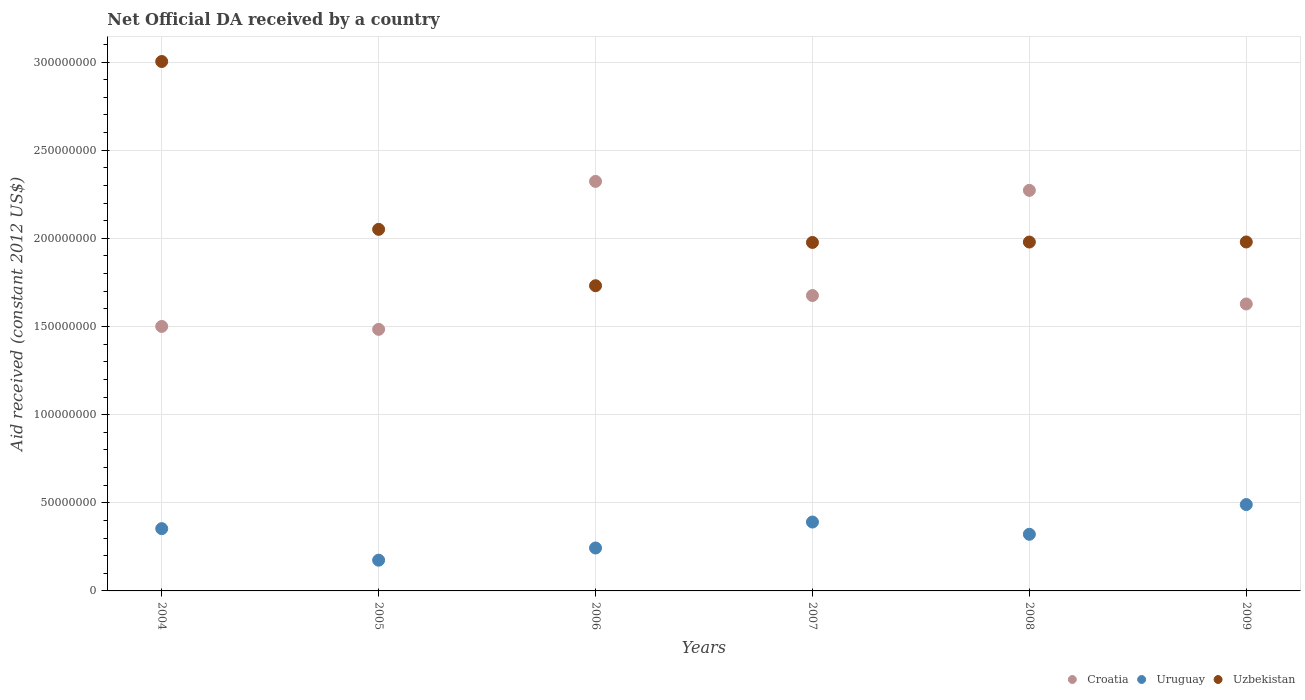How many different coloured dotlines are there?
Provide a succinct answer. 3. What is the net official development assistance aid received in Uruguay in 2008?
Your answer should be very brief. 3.21e+07. Across all years, what is the maximum net official development assistance aid received in Uruguay?
Offer a very short reply. 4.90e+07. Across all years, what is the minimum net official development assistance aid received in Uzbekistan?
Make the answer very short. 1.73e+08. In which year was the net official development assistance aid received in Uzbekistan maximum?
Make the answer very short. 2004. In which year was the net official development assistance aid received in Croatia minimum?
Make the answer very short. 2005. What is the total net official development assistance aid received in Croatia in the graph?
Ensure brevity in your answer.  1.09e+09. What is the difference between the net official development assistance aid received in Croatia in 2004 and that in 2007?
Provide a short and direct response. -1.75e+07. What is the difference between the net official development assistance aid received in Croatia in 2004 and the net official development assistance aid received in Uzbekistan in 2009?
Provide a succinct answer. -4.79e+07. What is the average net official development assistance aid received in Uruguay per year?
Your response must be concise. 3.29e+07. In the year 2007, what is the difference between the net official development assistance aid received in Croatia and net official development assistance aid received in Uruguay?
Your answer should be compact. 1.28e+08. In how many years, is the net official development assistance aid received in Uruguay greater than 130000000 US$?
Provide a succinct answer. 0. What is the ratio of the net official development assistance aid received in Uzbekistan in 2004 to that in 2008?
Your response must be concise. 1.52. What is the difference between the highest and the second highest net official development assistance aid received in Uzbekistan?
Provide a succinct answer. 9.52e+07. What is the difference between the highest and the lowest net official development assistance aid received in Uzbekistan?
Provide a succinct answer. 1.27e+08. In how many years, is the net official development assistance aid received in Croatia greater than the average net official development assistance aid received in Croatia taken over all years?
Give a very brief answer. 2. Is the sum of the net official development assistance aid received in Uzbekistan in 2004 and 2008 greater than the maximum net official development assistance aid received in Croatia across all years?
Make the answer very short. Yes. Does the net official development assistance aid received in Uzbekistan monotonically increase over the years?
Your answer should be compact. No. How many dotlines are there?
Ensure brevity in your answer.  3. Are the values on the major ticks of Y-axis written in scientific E-notation?
Ensure brevity in your answer.  No. Does the graph contain grids?
Make the answer very short. Yes. Where does the legend appear in the graph?
Ensure brevity in your answer.  Bottom right. How are the legend labels stacked?
Provide a succinct answer. Horizontal. What is the title of the graph?
Your answer should be very brief. Net Official DA received by a country. Does "Azerbaijan" appear as one of the legend labels in the graph?
Provide a succinct answer. No. What is the label or title of the Y-axis?
Your answer should be compact. Aid received (constant 2012 US$). What is the Aid received (constant 2012 US$) in Croatia in 2004?
Provide a short and direct response. 1.50e+08. What is the Aid received (constant 2012 US$) of Uruguay in 2004?
Your answer should be very brief. 3.53e+07. What is the Aid received (constant 2012 US$) of Uzbekistan in 2004?
Keep it short and to the point. 3.00e+08. What is the Aid received (constant 2012 US$) in Croatia in 2005?
Provide a short and direct response. 1.48e+08. What is the Aid received (constant 2012 US$) in Uruguay in 2005?
Provide a succinct answer. 1.74e+07. What is the Aid received (constant 2012 US$) of Uzbekistan in 2005?
Make the answer very short. 2.05e+08. What is the Aid received (constant 2012 US$) in Croatia in 2006?
Offer a very short reply. 2.32e+08. What is the Aid received (constant 2012 US$) in Uruguay in 2006?
Your answer should be compact. 2.44e+07. What is the Aid received (constant 2012 US$) of Uzbekistan in 2006?
Make the answer very short. 1.73e+08. What is the Aid received (constant 2012 US$) in Croatia in 2007?
Offer a terse response. 1.68e+08. What is the Aid received (constant 2012 US$) of Uruguay in 2007?
Offer a terse response. 3.91e+07. What is the Aid received (constant 2012 US$) of Uzbekistan in 2007?
Provide a short and direct response. 1.98e+08. What is the Aid received (constant 2012 US$) in Croatia in 2008?
Your response must be concise. 2.27e+08. What is the Aid received (constant 2012 US$) of Uruguay in 2008?
Your answer should be compact. 3.21e+07. What is the Aid received (constant 2012 US$) of Uzbekistan in 2008?
Offer a terse response. 1.98e+08. What is the Aid received (constant 2012 US$) of Croatia in 2009?
Provide a short and direct response. 1.63e+08. What is the Aid received (constant 2012 US$) of Uruguay in 2009?
Your answer should be very brief. 4.90e+07. What is the Aid received (constant 2012 US$) in Uzbekistan in 2009?
Provide a short and direct response. 1.98e+08. Across all years, what is the maximum Aid received (constant 2012 US$) in Croatia?
Make the answer very short. 2.32e+08. Across all years, what is the maximum Aid received (constant 2012 US$) in Uruguay?
Your response must be concise. 4.90e+07. Across all years, what is the maximum Aid received (constant 2012 US$) in Uzbekistan?
Your answer should be compact. 3.00e+08. Across all years, what is the minimum Aid received (constant 2012 US$) of Croatia?
Ensure brevity in your answer.  1.48e+08. Across all years, what is the minimum Aid received (constant 2012 US$) of Uruguay?
Your answer should be very brief. 1.74e+07. Across all years, what is the minimum Aid received (constant 2012 US$) in Uzbekistan?
Make the answer very short. 1.73e+08. What is the total Aid received (constant 2012 US$) in Croatia in the graph?
Keep it short and to the point. 1.09e+09. What is the total Aid received (constant 2012 US$) in Uruguay in the graph?
Provide a succinct answer. 1.97e+08. What is the total Aid received (constant 2012 US$) in Uzbekistan in the graph?
Your answer should be very brief. 1.27e+09. What is the difference between the Aid received (constant 2012 US$) in Croatia in 2004 and that in 2005?
Keep it short and to the point. 1.66e+06. What is the difference between the Aid received (constant 2012 US$) in Uruguay in 2004 and that in 2005?
Keep it short and to the point. 1.79e+07. What is the difference between the Aid received (constant 2012 US$) of Uzbekistan in 2004 and that in 2005?
Your answer should be compact. 9.52e+07. What is the difference between the Aid received (constant 2012 US$) in Croatia in 2004 and that in 2006?
Keep it short and to the point. -8.23e+07. What is the difference between the Aid received (constant 2012 US$) of Uruguay in 2004 and that in 2006?
Provide a short and direct response. 1.10e+07. What is the difference between the Aid received (constant 2012 US$) of Uzbekistan in 2004 and that in 2006?
Provide a succinct answer. 1.27e+08. What is the difference between the Aid received (constant 2012 US$) of Croatia in 2004 and that in 2007?
Offer a terse response. -1.75e+07. What is the difference between the Aid received (constant 2012 US$) in Uruguay in 2004 and that in 2007?
Keep it short and to the point. -3.74e+06. What is the difference between the Aid received (constant 2012 US$) in Uzbekistan in 2004 and that in 2007?
Keep it short and to the point. 1.03e+08. What is the difference between the Aid received (constant 2012 US$) of Croatia in 2004 and that in 2008?
Make the answer very short. -7.72e+07. What is the difference between the Aid received (constant 2012 US$) in Uruguay in 2004 and that in 2008?
Give a very brief answer. 3.20e+06. What is the difference between the Aid received (constant 2012 US$) of Uzbekistan in 2004 and that in 2008?
Make the answer very short. 1.02e+08. What is the difference between the Aid received (constant 2012 US$) in Croatia in 2004 and that in 2009?
Your answer should be compact. -1.27e+07. What is the difference between the Aid received (constant 2012 US$) in Uruguay in 2004 and that in 2009?
Provide a short and direct response. -1.36e+07. What is the difference between the Aid received (constant 2012 US$) in Uzbekistan in 2004 and that in 2009?
Ensure brevity in your answer.  1.02e+08. What is the difference between the Aid received (constant 2012 US$) in Croatia in 2005 and that in 2006?
Offer a terse response. -8.39e+07. What is the difference between the Aid received (constant 2012 US$) in Uruguay in 2005 and that in 2006?
Your answer should be very brief. -6.91e+06. What is the difference between the Aid received (constant 2012 US$) of Uzbekistan in 2005 and that in 2006?
Your response must be concise. 3.20e+07. What is the difference between the Aid received (constant 2012 US$) of Croatia in 2005 and that in 2007?
Ensure brevity in your answer.  -1.92e+07. What is the difference between the Aid received (constant 2012 US$) of Uruguay in 2005 and that in 2007?
Your response must be concise. -2.16e+07. What is the difference between the Aid received (constant 2012 US$) in Uzbekistan in 2005 and that in 2007?
Ensure brevity in your answer.  7.43e+06. What is the difference between the Aid received (constant 2012 US$) of Croatia in 2005 and that in 2008?
Your answer should be compact. -7.88e+07. What is the difference between the Aid received (constant 2012 US$) in Uruguay in 2005 and that in 2008?
Your answer should be compact. -1.47e+07. What is the difference between the Aid received (constant 2012 US$) in Uzbekistan in 2005 and that in 2008?
Provide a succinct answer. 7.20e+06. What is the difference between the Aid received (constant 2012 US$) of Croatia in 2005 and that in 2009?
Your answer should be compact. -1.44e+07. What is the difference between the Aid received (constant 2012 US$) of Uruguay in 2005 and that in 2009?
Provide a short and direct response. -3.15e+07. What is the difference between the Aid received (constant 2012 US$) in Uzbekistan in 2005 and that in 2009?
Your answer should be compact. 7.16e+06. What is the difference between the Aid received (constant 2012 US$) of Croatia in 2006 and that in 2007?
Your answer should be very brief. 6.48e+07. What is the difference between the Aid received (constant 2012 US$) of Uruguay in 2006 and that in 2007?
Provide a succinct answer. -1.47e+07. What is the difference between the Aid received (constant 2012 US$) of Uzbekistan in 2006 and that in 2007?
Provide a succinct answer. -2.45e+07. What is the difference between the Aid received (constant 2012 US$) of Croatia in 2006 and that in 2008?
Ensure brevity in your answer.  5.09e+06. What is the difference between the Aid received (constant 2012 US$) of Uruguay in 2006 and that in 2008?
Keep it short and to the point. -7.78e+06. What is the difference between the Aid received (constant 2012 US$) of Uzbekistan in 2006 and that in 2008?
Provide a short and direct response. -2.48e+07. What is the difference between the Aid received (constant 2012 US$) in Croatia in 2006 and that in 2009?
Provide a short and direct response. 6.95e+07. What is the difference between the Aid received (constant 2012 US$) of Uruguay in 2006 and that in 2009?
Your answer should be compact. -2.46e+07. What is the difference between the Aid received (constant 2012 US$) in Uzbekistan in 2006 and that in 2009?
Provide a succinct answer. -2.48e+07. What is the difference between the Aid received (constant 2012 US$) in Croatia in 2007 and that in 2008?
Your response must be concise. -5.97e+07. What is the difference between the Aid received (constant 2012 US$) of Uruguay in 2007 and that in 2008?
Your response must be concise. 6.94e+06. What is the difference between the Aid received (constant 2012 US$) in Uzbekistan in 2007 and that in 2008?
Your answer should be compact. -2.30e+05. What is the difference between the Aid received (constant 2012 US$) of Croatia in 2007 and that in 2009?
Provide a succinct answer. 4.78e+06. What is the difference between the Aid received (constant 2012 US$) of Uruguay in 2007 and that in 2009?
Provide a succinct answer. -9.91e+06. What is the difference between the Aid received (constant 2012 US$) of Uzbekistan in 2007 and that in 2009?
Offer a terse response. -2.70e+05. What is the difference between the Aid received (constant 2012 US$) in Croatia in 2008 and that in 2009?
Offer a terse response. 6.44e+07. What is the difference between the Aid received (constant 2012 US$) in Uruguay in 2008 and that in 2009?
Offer a very short reply. -1.68e+07. What is the difference between the Aid received (constant 2012 US$) in Uzbekistan in 2008 and that in 2009?
Offer a very short reply. -4.00e+04. What is the difference between the Aid received (constant 2012 US$) of Croatia in 2004 and the Aid received (constant 2012 US$) of Uruguay in 2005?
Provide a succinct answer. 1.33e+08. What is the difference between the Aid received (constant 2012 US$) in Croatia in 2004 and the Aid received (constant 2012 US$) in Uzbekistan in 2005?
Provide a short and direct response. -5.51e+07. What is the difference between the Aid received (constant 2012 US$) in Uruguay in 2004 and the Aid received (constant 2012 US$) in Uzbekistan in 2005?
Provide a short and direct response. -1.70e+08. What is the difference between the Aid received (constant 2012 US$) of Croatia in 2004 and the Aid received (constant 2012 US$) of Uruguay in 2006?
Your response must be concise. 1.26e+08. What is the difference between the Aid received (constant 2012 US$) in Croatia in 2004 and the Aid received (constant 2012 US$) in Uzbekistan in 2006?
Ensure brevity in your answer.  -2.31e+07. What is the difference between the Aid received (constant 2012 US$) in Uruguay in 2004 and the Aid received (constant 2012 US$) in Uzbekistan in 2006?
Ensure brevity in your answer.  -1.38e+08. What is the difference between the Aid received (constant 2012 US$) in Croatia in 2004 and the Aid received (constant 2012 US$) in Uruguay in 2007?
Offer a terse response. 1.11e+08. What is the difference between the Aid received (constant 2012 US$) in Croatia in 2004 and the Aid received (constant 2012 US$) in Uzbekistan in 2007?
Offer a terse response. -4.76e+07. What is the difference between the Aid received (constant 2012 US$) in Uruguay in 2004 and the Aid received (constant 2012 US$) in Uzbekistan in 2007?
Offer a terse response. -1.62e+08. What is the difference between the Aid received (constant 2012 US$) of Croatia in 2004 and the Aid received (constant 2012 US$) of Uruguay in 2008?
Ensure brevity in your answer.  1.18e+08. What is the difference between the Aid received (constant 2012 US$) of Croatia in 2004 and the Aid received (constant 2012 US$) of Uzbekistan in 2008?
Provide a succinct answer. -4.79e+07. What is the difference between the Aid received (constant 2012 US$) of Uruguay in 2004 and the Aid received (constant 2012 US$) of Uzbekistan in 2008?
Offer a very short reply. -1.63e+08. What is the difference between the Aid received (constant 2012 US$) in Croatia in 2004 and the Aid received (constant 2012 US$) in Uruguay in 2009?
Make the answer very short. 1.01e+08. What is the difference between the Aid received (constant 2012 US$) of Croatia in 2004 and the Aid received (constant 2012 US$) of Uzbekistan in 2009?
Make the answer very short. -4.79e+07. What is the difference between the Aid received (constant 2012 US$) of Uruguay in 2004 and the Aid received (constant 2012 US$) of Uzbekistan in 2009?
Your answer should be very brief. -1.63e+08. What is the difference between the Aid received (constant 2012 US$) in Croatia in 2005 and the Aid received (constant 2012 US$) in Uruguay in 2006?
Offer a terse response. 1.24e+08. What is the difference between the Aid received (constant 2012 US$) of Croatia in 2005 and the Aid received (constant 2012 US$) of Uzbekistan in 2006?
Give a very brief answer. -2.48e+07. What is the difference between the Aid received (constant 2012 US$) of Uruguay in 2005 and the Aid received (constant 2012 US$) of Uzbekistan in 2006?
Make the answer very short. -1.56e+08. What is the difference between the Aid received (constant 2012 US$) in Croatia in 2005 and the Aid received (constant 2012 US$) in Uruguay in 2007?
Your answer should be compact. 1.09e+08. What is the difference between the Aid received (constant 2012 US$) of Croatia in 2005 and the Aid received (constant 2012 US$) of Uzbekistan in 2007?
Ensure brevity in your answer.  -4.93e+07. What is the difference between the Aid received (constant 2012 US$) in Uruguay in 2005 and the Aid received (constant 2012 US$) in Uzbekistan in 2007?
Offer a terse response. -1.80e+08. What is the difference between the Aid received (constant 2012 US$) in Croatia in 2005 and the Aid received (constant 2012 US$) in Uruguay in 2008?
Provide a succinct answer. 1.16e+08. What is the difference between the Aid received (constant 2012 US$) in Croatia in 2005 and the Aid received (constant 2012 US$) in Uzbekistan in 2008?
Your response must be concise. -4.95e+07. What is the difference between the Aid received (constant 2012 US$) of Uruguay in 2005 and the Aid received (constant 2012 US$) of Uzbekistan in 2008?
Offer a very short reply. -1.80e+08. What is the difference between the Aid received (constant 2012 US$) in Croatia in 2005 and the Aid received (constant 2012 US$) in Uruguay in 2009?
Your response must be concise. 9.94e+07. What is the difference between the Aid received (constant 2012 US$) in Croatia in 2005 and the Aid received (constant 2012 US$) in Uzbekistan in 2009?
Offer a terse response. -4.96e+07. What is the difference between the Aid received (constant 2012 US$) of Uruguay in 2005 and the Aid received (constant 2012 US$) of Uzbekistan in 2009?
Keep it short and to the point. -1.80e+08. What is the difference between the Aid received (constant 2012 US$) in Croatia in 2006 and the Aid received (constant 2012 US$) in Uruguay in 2007?
Offer a terse response. 1.93e+08. What is the difference between the Aid received (constant 2012 US$) in Croatia in 2006 and the Aid received (constant 2012 US$) in Uzbekistan in 2007?
Keep it short and to the point. 3.46e+07. What is the difference between the Aid received (constant 2012 US$) in Uruguay in 2006 and the Aid received (constant 2012 US$) in Uzbekistan in 2007?
Offer a very short reply. -1.73e+08. What is the difference between the Aid received (constant 2012 US$) of Croatia in 2006 and the Aid received (constant 2012 US$) of Uruguay in 2008?
Give a very brief answer. 2.00e+08. What is the difference between the Aid received (constant 2012 US$) of Croatia in 2006 and the Aid received (constant 2012 US$) of Uzbekistan in 2008?
Your answer should be very brief. 3.44e+07. What is the difference between the Aid received (constant 2012 US$) of Uruguay in 2006 and the Aid received (constant 2012 US$) of Uzbekistan in 2008?
Give a very brief answer. -1.74e+08. What is the difference between the Aid received (constant 2012 US$) in Croatia in 2006 and the Aid received (constant 2012 US$) in Uruguay in 2009?
Provide a succinct answer. 1.83e+08. What is the difference between the Aid received (constant 2012 US$) in Croatia in 2006 and the Aid received (constant 2012 US$) in Uzbekistan in 2009?
Provide a succinct answer. 3.44e+07. What is the difference between the Aid received (constant 2012 US$) in Uruguay in 2006 and the Aid received (constant 2012 US$) in Uzbekistan in 2009?
Offer a very short reply. -1.74e+08. What is the difference between the Aid received (constant 2012 US$) of Croatia in 2007 and the Aid received (constant 2012 US$) of Uruguay in 2008?
Keep it short and to the point. 1.35e+08. What is the difference between the Aid received (constant 2012 US$) in Croatia in 2007 and the Aid received (constant 2012 US$) in Uzbekistan in 2008?
Provide a succinct answer. -3.04e+07. What is the difference between the Aid received (constant 2012 US$) in Uruguay in 2007 and the Aid received (constant 2012 US$) in Uzbekistan in 2008?
Make the answer very short. -1.59e+08. What is the difference between the Aid received (constant 2012 US$) of Croatia in 2007 and the Aid received (constant 2012 US$) of Uruguay in 2009?
Your answer should be very brief. 1.19e+08. What is the difference between the Aid received (constant 2012 US$) in Croatia in 2007 and the Aid received (constant 2012 US$) in Uzbekistan in 2009?
Make the answer very short. -3.04e+07. What is the difference between the Aid received (constant 2012 US$) of Uruguay in 2007 and the Aid received (constant 2012 US$) of Uzbekistan in 2009?
Your response must be concise. -1.59e+08. What is the difference between the Aid received (constant 2012 US$) in Croatia in 2008 and the Aid received (constant 2012 US$) in Uruguay in 2009?
Your answer should be compact. 1.78e+08. What is the difference between the Aid received (constant 2012 US$) in Croatia in 2008 and the Aid received (constant 2012 US$) in Uzbekistan in 2009?
Provide a succinct answer. 2.93e+07. What is the difference between the Aid received (constant 2012 US$) of Uruguay in 2008 and the Aid received (constant 2012 US$) of Uzbekistan in 2009?
Provide a short and direct response. -1.66e+08. What is the average Aid received (constant 2012 US$) of Croatia per year?
Provide a short and direct response. 1.81e+08. What is the average Aid received (constant 2012 US$) in Uruguay per year?
Your response must be concise. 3.29e+07. What is the average Aid received (constant 2012 US$) of Uzbekistan per year?
Keep it short and to the point. 2.12e+08. In the year 2004, what is the difference between the Aid received (constant 2012 US$) in Croatia and Aid received (constant 2012 US$) in Uruguay?
Keep it short and to the point. 1.15e+08. In the year 2004, what is the difference between the Aid received (constant 2012 US$) of Croatia and Aid received (constant 2012 US$) of Uzbekistan?
Offer a very short reply. -1.50e+08. In the year 2004, what is the difference between the Aid received (constant 2012 US$) in Uruguay and Aid received (constant 2012 US$) in Uzbekistan?
Ensure brevity in your answer.  -2.65e+08. In the year 2005, what is the difference between the Aid received (constant 2012 US$) in Croatia and Aid received (constant 2012 US$) in Uruguay?
Keep it short and to the point. 1.31e+08. In the year 2005, what is the difference between the Aid received (constant 2012 US$) of Croatia and Aid received (constant 2012 US$) of Uzbekistan?
Your response must be concise. -5.67e+07. In the year 2005, what is the difference between the Aid received (constant 2012 US$) of Uruguay and Aid received (constant 2012 US$) of Uzbekistan?
Provide a succinct answer. -1.88e+08. In the year 2006, what is the difference between the Aid received (constant 2012 US$) in Croatia and Aid received (constant 2012 US$) in Uruguay?
Your answer should be compact. 2.08e+08. In the year 2006, what is the difference between the Aid received (constant 2012 US$) of Croatia and Aid received (constant 2012 US$) of Uzbekistan?
Provide a short and direct response. 5.92e+07. In the year 2006, what is the difference between the Aid received (constant 2012 US$) in Uruguay and Aid received (constant 2012 US$) in Uzbekistan?
Your answer should be very brief. -1.49e+08. In the year 2007, what is the difference between the Aid received (constant 2012 US$) of Croatia and Aid received (constant 2012 US$) of Uruguay?
Keep it short and to the point. 1.28e+08. In the year 2007, what is the difference between the Aid received (constant 2012 US$) of Croatia and Aid received (constant 2012 US$) of Uzbekistan?
Your answer should be very brief. -3.01e+07. In the year 2007, what is the difference between the Aid received (constant 2012 US$) in Uruguay and Aid received (constant 2012 US$) in Uzbekistan?
Offer a very short reply. -1.59e+08. In the year 2008, what is the difference between the Aid received (constant 2012 US$) of Croatia and Aid received (constant 2012 US$) of Uruguay?
Provide a short and direct response. 1.95e+08. In the year 2008, what is the difference between the Aid received (constant 2012 US$) of Croatia and Aid received (constant 2012 US$) of Uzbekistan?
Your response must be concise. 2.93e+07. In the year 2008, what is the difference between the Aid received (constant 2012 US$) of Uruguay and Aid received (constant 2012 US$) of Uzbekistan?
Make the answer very short. -1.66e+08. In the year 2009, what is the difference between the Aid received (constant 2012 US$) of Croatia and Aid received (constant 2012 US$) of Uruguay?
Make the answer very short. 1.14e+08. In the year 2009, what is the difference between the Aid received (constant 2012 US$) in Croatia and Aid received (constant 2012 US$) in Uzbekistan?
Offer a terse response. -3.52e+07. In the year 2009, what is the difference between the Aid received (constant 2012 US$) of Uruguay and Aid received (constant 2012 US$) of Uzbekistan?
Your answer should be very brief. -1.49e+08. What is the ratio of the Aid received (constant 2012 US$) of Croatia in 2004 to that in 2005?
Keep it short and to the point. 1.01. What is the ratio of the Aid received (constant 2012 US$) in Uruguay in 2004 to that in 2005?
Offer a terse response. 2.03. What is the ratio of the Aid received (constant 2012 US$) in Uzbekistan in 2004 to that in 2005?
Your answer should be very brief. 1.46. What is the ratio of the Aid received (constant 2012 US$) of Croatia in 2004 to that in 2006?
Offer a very short reply. 0.65. What is the ratio of the Aid received (constant 2012 US$) of Uruguay in 2004 to that in 2006?
Your answer should be very brief. 1.45. What is the ratio of the Aid received (constant 2012 US$) of Uzbekistan in 2004 to that in 2006?
Your response must be concise. 1.73. What is the ratio of the Aid received (constant 2012 US$) of Croatia in 2004 to that in 2007?
Give a very brief answer. 0.9. What is the ratio of the Aid received (constant 2012 US$) in Uruguay in 2004 to that in 2007?
Keep it short and to the point. 0.9. What is the ratio of the Aid received (constant 2012 US$) in Uzbekistan in 2004 to that in 2007?
Your answer should be very brief. 1.52. What is the ratio of the Aid received (constant 2012 US$) of Croatia in 2004 to that in 2008?
Your answer should be very brief. 0.66. What is the ratio of the Aid received (constant 2012 US$) in Uruguay in 2004 to that in 2008?
Give a very brief answer. 1.1. What is the ratio of the Aid received (constant 2012 US$) of Uzbekistan in 2004 to that in 2008?
Give a very brief answer. 1.52. What is the ratio of the Aid received (constant 2012 US$) of Croatia in 2004 to that in 2009?
Provide a short and direct response. 0.92. What is the ratio of the Aid received (constant 2012 US$) in Uruguay in 2004 to that in 2009?
Make the answer very short. 0.72. What is the ratio of the Aid received (constant 2012 US$) in Uzbekistan in 2004 to that in 2009?
Provide a short and direct response. 1.52. What is the ratio of the Aid received (constant 2012 US$) in Croatia in 2005 to that in 2006?
Give a very brief answer. 0.64. What is the ratio of the Aid received (constant 2012 US$) of Uruguay in 2005 to that in 2006?
Your answer should be very brief. 0.72. What is the ratio of the Aid received (constant 2012 US$) of Uzbekistan in 2005 to that in 2006?
Provide a short and direct response. 1.18. What is the ratio of the Aid received (constant 2012 US$) of Croatia in 2005 to that in 2007?
Your response must be concise. 0.89. What is the ratio of the Aid received (constant 2012 US$) of Uruguay in 2005 to that in 2007?
Offer a terse response. 0.45. What is the ratio of the Aid received (constant 2012 US$) in Uzbekistan in 2005 to that in 2007?
Your answer should be very brief. 1.04. What is the ratio of the Aid received (constant 2012 US$) in Croatia in 2005 to that in 2008?
Your answer should be compact. 0.65. What is the ratio of the Aid received (constant 2012 US$) of Uruguay in 2005 to that in 2008?
Offer a very short reply. 0.54. What is the ratio of the Aid received (constant 2012 US$) of Uzbekistan in 2005 to that in 2008?
Provide a succinct answer. 1.04. What is the ratio of the Aid received (constant 2012 US$) of Croatia in 2005 to that in 2009?
Offer a very short reply. 0.91. What is the ratio of the Aid received (constant 2012 US$) in Uruguay in 2005 to that in 2009?
Offer a very short reply. 0.36. What is the ratio of the Aid received (constant 2012 US$) of Uzbekistan in 2005 to that in 2009?
Keep it short and to the point. 1.04. What is the ratio of the Aid received (constant 2012 US$) in Croatia in 2006 to that in 2007?
Your answer should be compact. 1.39. What is the ratio of the Aid received (constant 2012 US$) of Uruguay in 2006 to that in 2007?
Your answer should be compact. 0.62. What is the ratio of the Aid received (constant 2012 US$) of Uzbekistan in 2006 to that in 2007?
Your answer should be compact. 0.88. What is the ratio of the Aid received (constant 2012 US$) of Croatia in 2006 to that in 2008?
Offer a very short reply. 1.02. What is the ratio of the Aid received (constant 2012 US$) of Uruguay in 2006 to that in 2008?
Ensure brevity in your answer.  0.76. What is the ratio of the Aid received (constant 2012 US$) in Uzbekistan in 2006 to that in 2008?
Your response must be concise. 0.87. What is the ratio of the Aid received (constant 2012 US$) of Croatia in 2006 to that in 2009?
Offer a terse response. 1.43. What is the ratio of the Aid received (constant 2012 US$) in Uruguay in 2006 to that in 2009?
Offer a very short reply. 0.5. What is the ratio of the Aid received (constant 2012 US$) in Uzbekistan in 2006 to that in 2009?
Keep it short and to the point. 0.87. What is the ratio of the Aid received (constant 2012 US$) of Croatia in 2007 to that in 2008?
Provide a short and direct response. 0.74. What is the ratio of the Aid received (constant 2012 US$) in Uruguay in 2007 to that in 2008?
Your answer should be very brief. 1.22. What is the ratio of the Aid received (constant 2012 US$) of Croatia in 2007 to that in 2009?
Offer a terse response. 1.03. What is the ratio of the Aid received (constant 2012 US$) in Uruguay in 2007 to that in 2009?
Ensure brevity in your answer.  0.8. What is the ratio of the Aid received (constant 2012 US$) in Croatia in 2008 to that in 2009?
Offer a terse response. 1.4. What is the ratio of the Aid received (constant 2012 US$) of Uruguay in 2008 to that in 2009?
Offer a very short reply. 0.66. What is the difference between the highest and the second highest Aid received (constant 2012 US$) in Croatia?
Offer a very short reply. 5.09e+06. What is the difference between the highest and the second highest Aid received (constant 2012 US$) in Uruguay?
Your response must be concise. 9.91e+06. What is the difference between the highest and the second highest Aid received (constant 2012 US$) in Uzbekistan?
Keep it short and to the point. 9.52e+07. What is the difference between the highest and the lowest Aid received (constant 2012 US$) of Croatia?
Your answer should be compact. 8.39e+07. What is the difference between the highest and the lowest Aid received (constant 2012 US$) of Uruguay?
Offer a very short reply. 3.15e+07. What is the difference between the highest and the lowest Aid received (constant 2012 US$) in Uzbekistan?
Provide a succinct answer. 1.27e+08. 